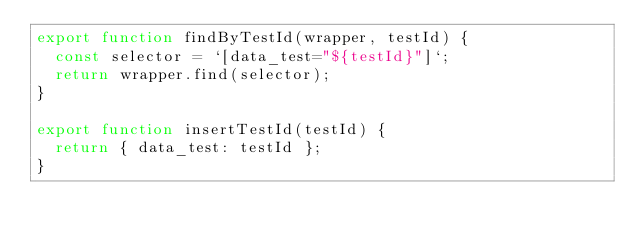Convert code to text. <code><loc_0><loc_0><loc_500><loc_500><_JavaScript_>export function findByTestId(wrapper, testId) {
  const selector = `[data_test="${testId}"]`;
  return wrapper.find(selector);
}

export function insertTestId(testId) {
  return { data_test: testId };
}
</code> 